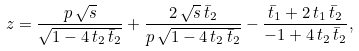Convert formula to latex. <formula><loc_0><loc_0><loc_500><loc_500>z = { \frac { p \, { \sqrt { s } } } { { \sqrt { 1 - 4 \, t _ { 2 } \, \bar { t } _ { 2 } } } } } + { \frac { 2 \, { \sqrt { s } } \, \bar { t } _ { 2 } } { p \, { \sqrt { 1 - 4 \, t _ { 2 } \, \bar { t } _ { 2 } } } } } - { \frac { \bar { t } _ { 1 } + 2 \, t _ { 1 } \, \bar { t } _ { 2 } } { - 1 + 4 \, t _ { 2 } \, \bar { t } _ { 2 } } } ,</formula> 